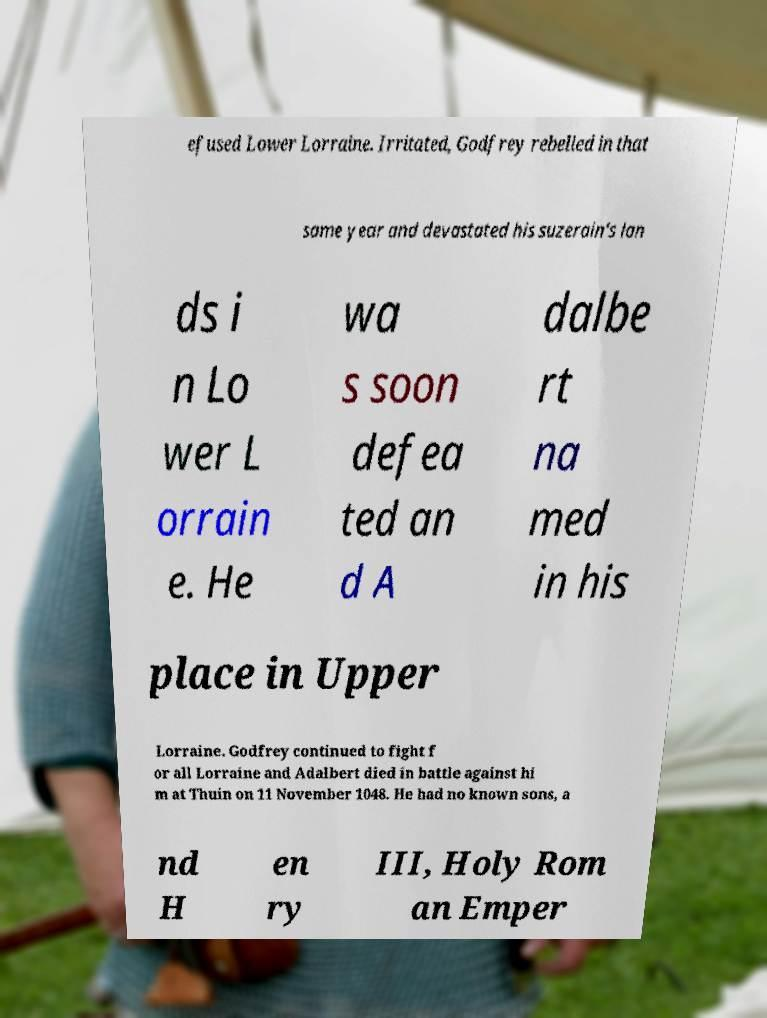There's text embedded in this image that I need extracted. Can you transcribe it verbatim? efused Lower Lorraine. Irritated, Godfrey rebelled in that same year and devastated his suzerain's lan ds i n Lo wer L orrain e. He wa s soon defea ted an d A dalbe rt na med in his place in Upper Lorraine. Godfrey continued to fight f or all Lorraine and Adalbert died in battle against hi m at Thuin on 11 November 1048. He had no known sons, a nd H en ry III, Holy Rom an Emper 